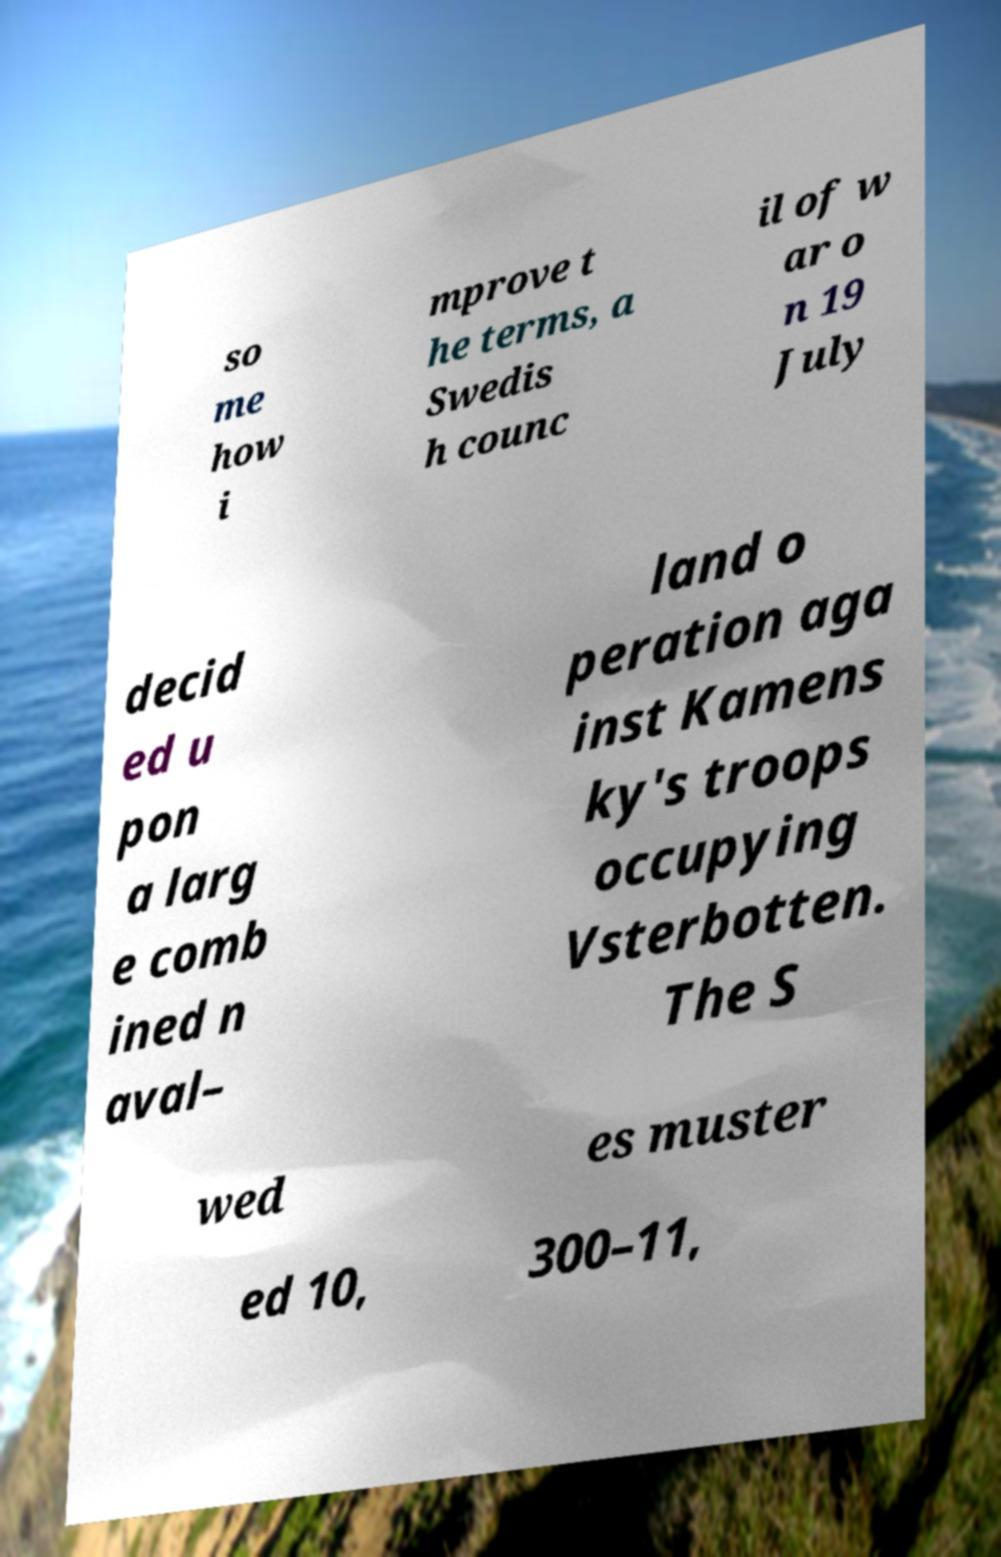Please read and relay the text visible in this image. What does it say? so me how i mprove t he terms, a Swedis h counc il of w ar o n 19 July decid ed u pon a larg e comb ined n aval– land o peration aga inst Kamens ky's troops occupying Vsterbotten. The S wed es muster ed 10, 300–11, 